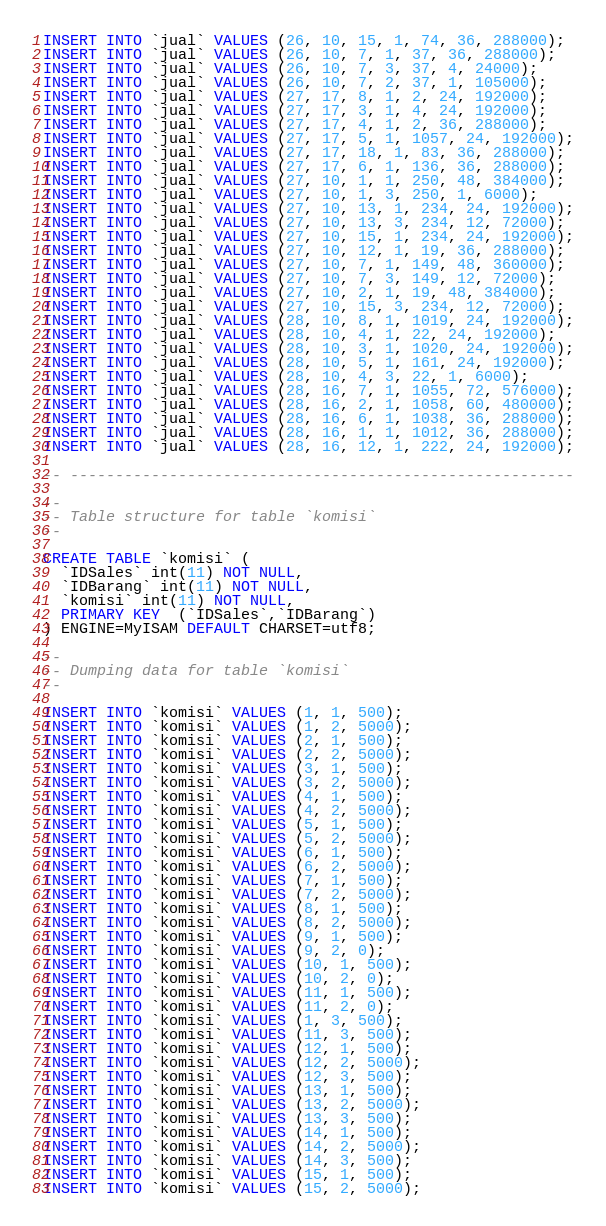<code> <loc_0><loc_0><loc_500><loc_500><_SQL_>INSERT INTO `jual` VALUES (26, 10, 15, 1, 74, 36, 288000);
INSERT INTO `jual` VALUES (26, 10, 7, 1, 37, 36, 288000);
INSERT INTO `jual` VALUES (26, 10, 7, 3, 37, 4, 24000);
INSERT INTO `jual` VALUES (26, 10, 7, 2, 37, 1, 105000);
INSERT INTO `jual` VALUES (27, 17, 8, 1, 2, 24, 192000);
INSERT INTO `jual` VALUES (27, 17, 3, 1, 4, 24, 192000);
INSERT INTO `jual` VALUES (27, 17, 4, 1, 2, 36, 288000);
INSERT INTO `jual` VALUES (27, 17, 5, 1, 1057, 24, 192000);
INSERT INTO `jual` VALUES (27, 17, 18, 1, 83, 36, 288000);
INSERT INTO `jual` VALUES (27, 17, 6, 1, 136, 36, 288000);
INSERT INTO `jual` VALUES (27, 10, 1, 1, 250, 48, 384000);
INSERT INTO `jual` VALUES (27, 10, 1, 3, 250, 1, 6000);
INSERT INTO `jual` VALUES (27, 10, 13, 1, 234, 24, 192000);
INSERT INTO `jual` VALUES (27, 10, 13, 3, 234, 12, 72000);
INSERT INTO `jual` VALUES (27, 10, 15, 1, 234, 24, 192000);
INSERT INTO `jual` VALUES (27, 10, 12, 1, 19, 36, 288000);
INSERT INTO `jual` VALUES (27, 10, 7, 1, 149, 48, 360000);
INSERT INTO `jual` VALUES (27, 10, 7, 3, 149, 12, 72000);
INSERT INTO `jual` VALUES (27, 10, 2, 1, 19, 48, 384000);
INSERT INTO `jual` VALUES (27, 10, 15, 3, 234, 12, 72000);
INSERT INTO `jual` VALUES (28, 10, 8, 1, 1019, 24, 192000);
INSERT INTO `jual` VALUES (28, 10, 4, 1, 22, 24, 192000);
INSERT INTO `jual` VALUES (28, 10, 3, 1, 1020, 24, 192000);
INSERT INTO `jual` VALUES (28, 10, 5, 1, 161, 24, 192000);
INSERT INTO `jual` VALUES (28, 10, 4, 3, 22, 1, 6000);
INSERT INTO `jual` VALUES (28, 16, 7, 1, 1055, 72, 576000);
INSERT INTO `jual` VALUES (28, 16, 2, 1, 1058, 60, 480000);
INSERT INTO `jual` VALUES (28, 16, 6, 1, 1038, 36, 288000);
INSERT INTO `jual` VALUES (28, 16, 1, 1, 1012, 36, 288000);
INSERT INTO `jual` VALUES (28, 16, 12, 1, 222, 24, 192000);

-- --------------------------------------------------------

-- 
-- Table structure for table `komisi`
-- 

CREATE TABLE `komisi` (
  `IDSales` int(11) NOT NULL,
  `IDBarang` int(11) NOT NULL,
  `komisi` int(11) NOT NULL,
  PRIMARY KEY  (`IDSales`,`IDBarang`)
) ENGINE=MyISAM DEFAULT CHARSET=utf8;

-- 
-- Dumping data for table `komisi`
-- 

INSERT INTO `komisi` VALUES (1, 1, 500);
INSERT INTO `komisi` VALUES (1, 2, 5000);
INSERT INTO `komisi` VALUES (2, 1, 500);
INSERT INTO `komisi` VALUES (2, 2, 5000);
INSERT INTO `komisi` VALUES (3, 1, 500);
INSERT INTO `komisi` VALUES (3, 2, 5000);
INSERT INTO `komisi` VALUES (4, 1, 500);
INSERT INTO `komisi` VALUES (4, 2, 5000);
INSERT INTO `komisi` VALUES (5, 1, 500);
INSERT INTO `komisi` VALUES (5, 2, 5000);
INSERT INTO `komisi` VALUES (6, 1, 500);
INSERT INTO `komisi` VALUES (6, 2, 5000);
INSERT INTO `komisi` VALUES (7, 1, 500);
INSERT INTO `komisi` VALUES (7, 2, 5000);
INSERT INTO `komisi` VALUES (8, 1, 500);
INSERT INTO `komisi` VALUES (8, 2, 5000);
INSERT INTO `komisi` VALUES (9, 1, 500);
INSERT INTO `komisi` VALUES (9, 2, 0);
INSERT INTO `komisi` VALUES (10, 1, 500);
INSERT INTO `komisi` VALUES (10, 2, 0);
INSERT INTO `komisi` VALUES (11, 1, 500);
INSERT INTO `komisi` VALUES (11, 2, 0);
INSERT INTO `komisi` VALUES (1, 3, 500);
INSERT INTO `komisi` VALUES (11, 3, 500);
INSERT INTO `komisi` VALUES (12, 1, 500);
INSERT INTO `komisi` VALUES (12, 2, 5000);
INSERT INTO `komisi` VALUES (12, 3, 500);
INSERT INTO `komisi` VALUES (13, 1, 500);
INSERT INTO `komisi` VALUES (13, 2, 5000);
INSERT INTO `komisi` VALUES (13, 3, 500);
INSERT INTO `komisi` VALUES (14, 1, 500);
INSERT INTO `komisi` VALUES (14, 2, 5000);
INSERT INTO `komisi` VALUES (14, 3, 500);
INSERT INTO `komisi` VALUES (15, 1, 500);
INSERT INTO `komisi` VALUES (15, 2, 5000);</code> 